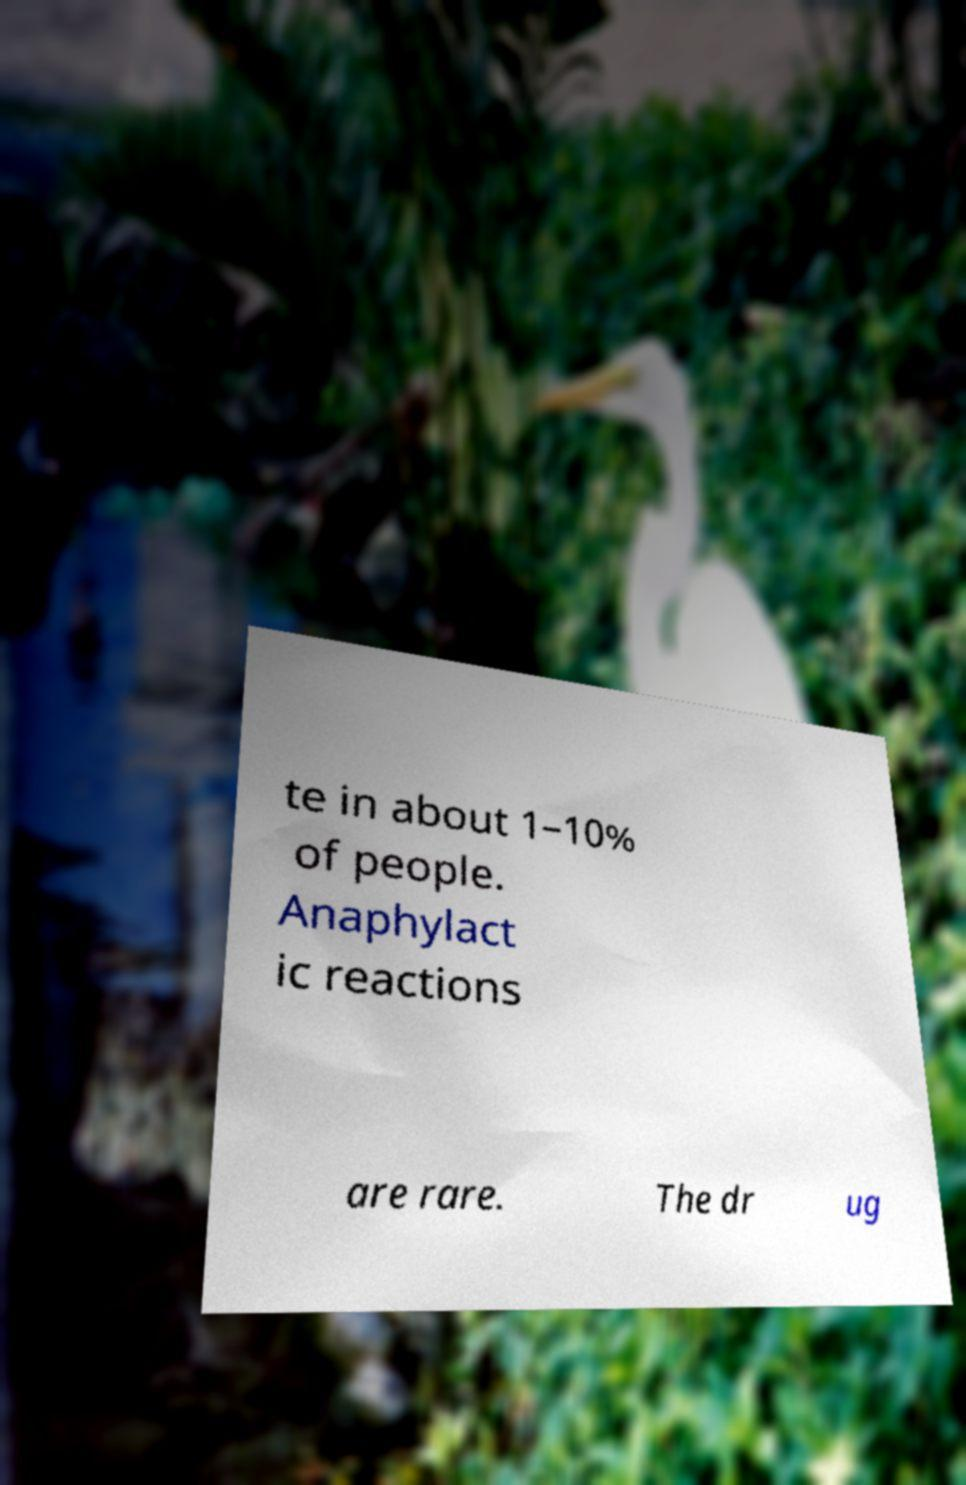Can you read and provide the text displayed in the image?This photo seems to have some interesting text. Can you extract and type it out for me? te in about 1–10% of people. Anaphylact ic reactions are rare. The dr ug 